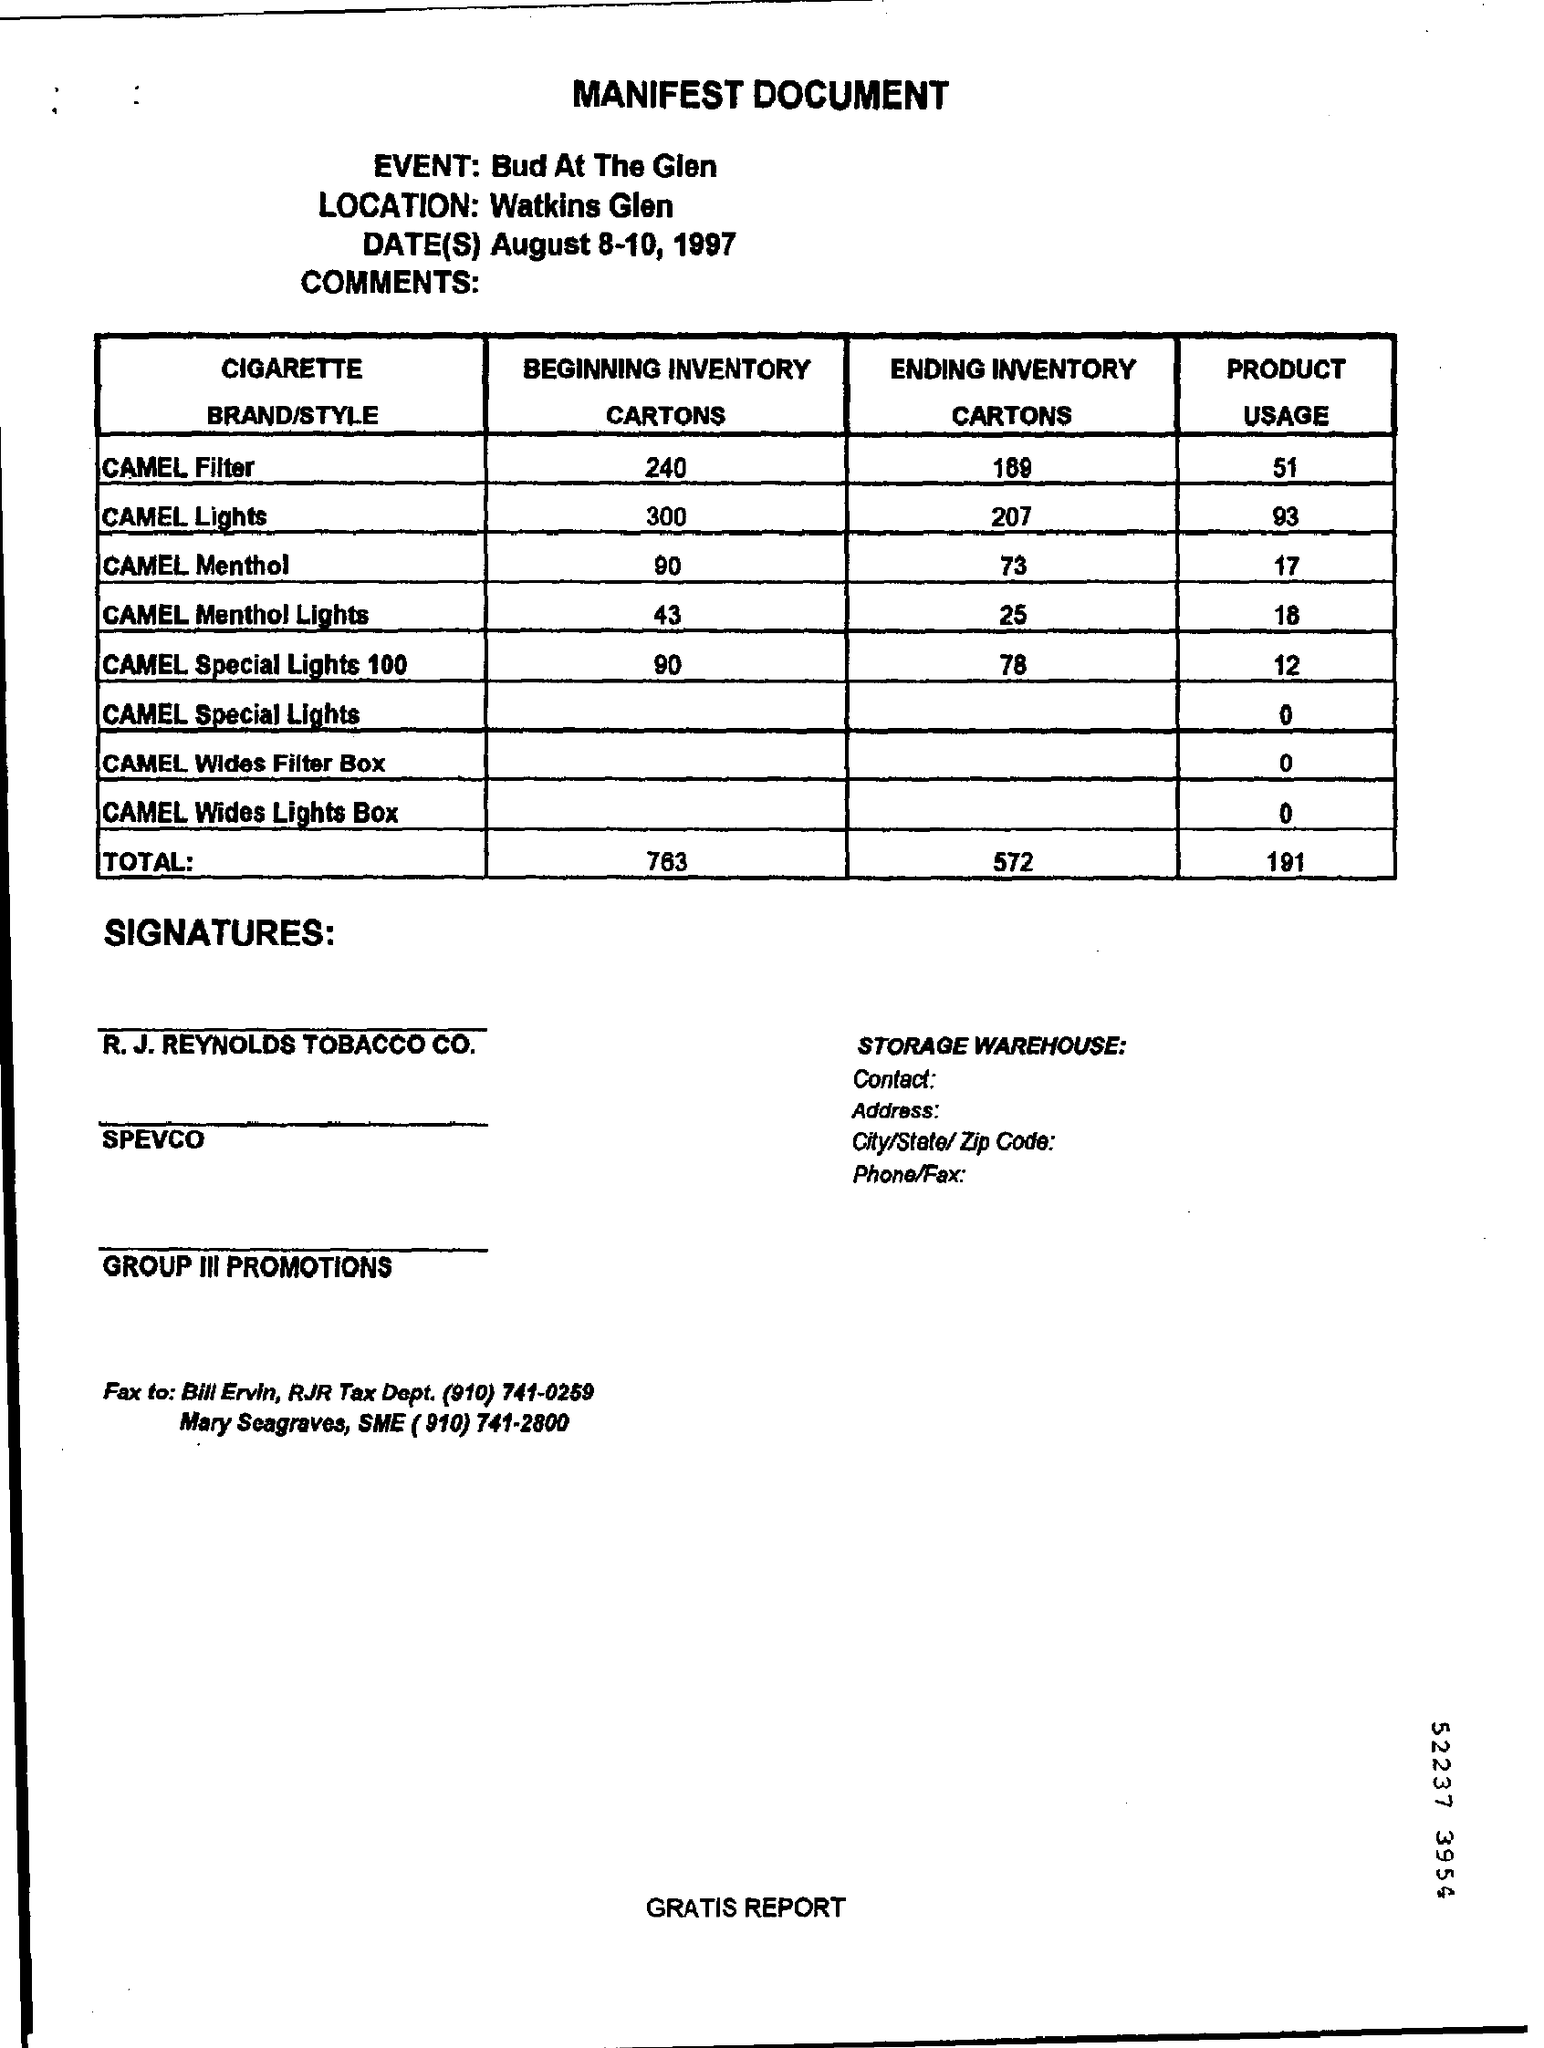Indicate a few pertinent items in this graphic. This is a manifest document. The beginning inventory of CAMEL Menthol is 90 units. Watkins Glen is the location mentioned in the heading. 